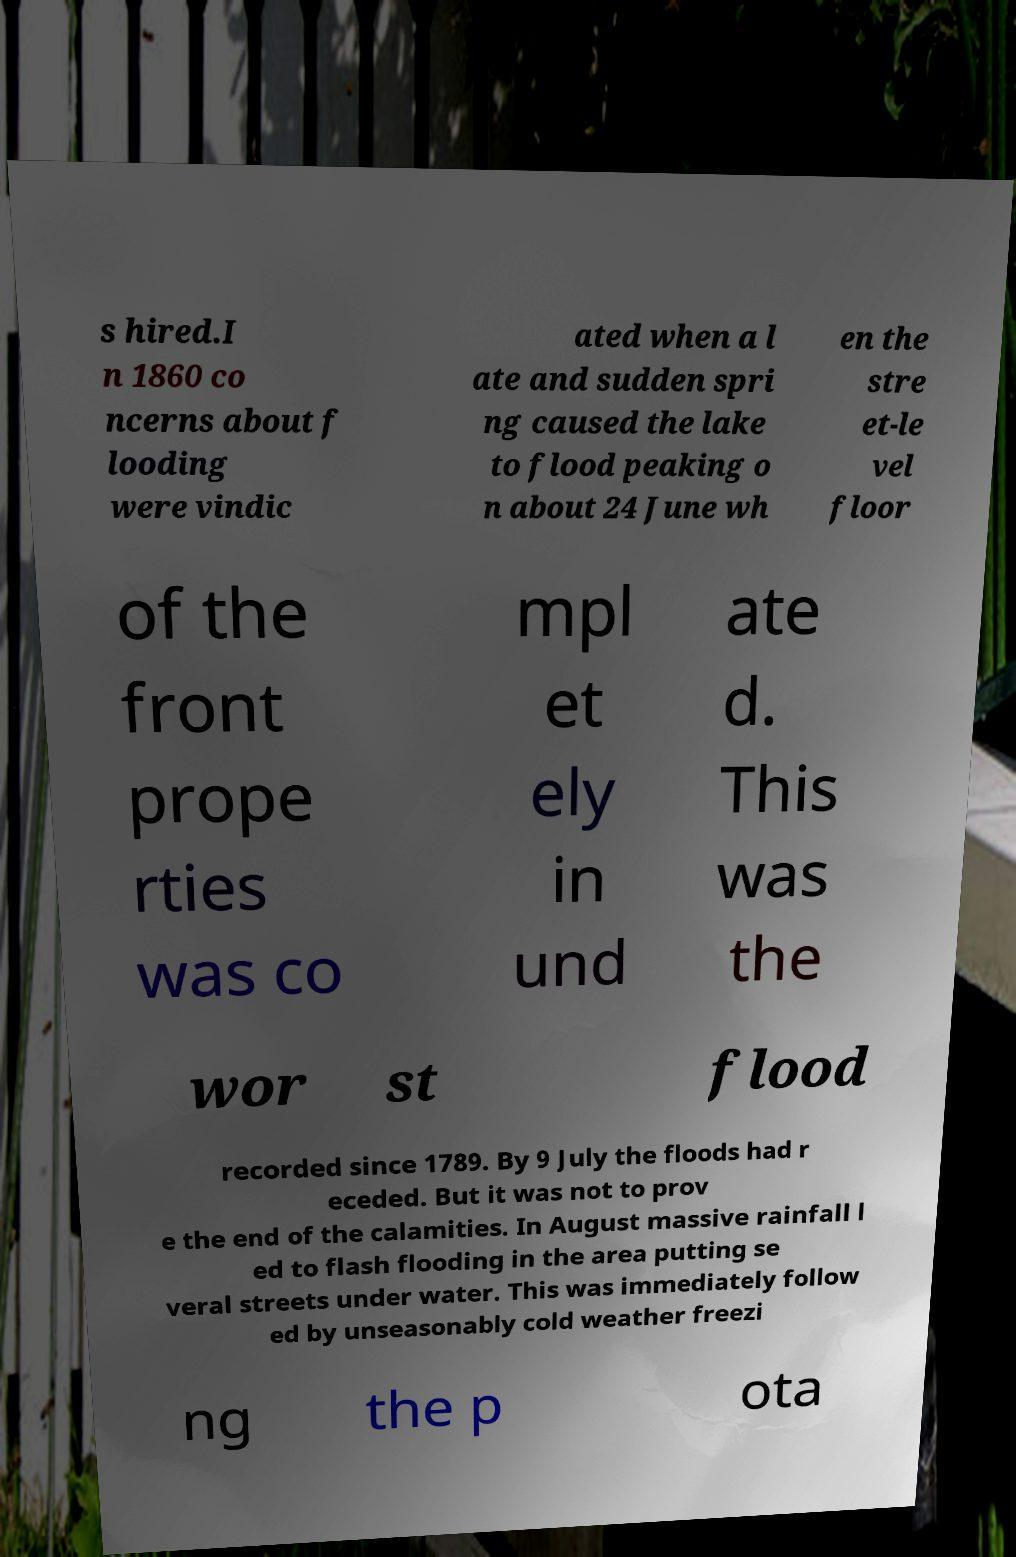Could you assist in decoding the text presented in this image and type it out clearly? s hired.I n 1860 co ncerns about f looding were vindic ated when a l ate and sudden spri ng caused the lake to flood peaking o n about 24 June wh en the stre et-le vel floor of the front prope rties was co mpl et ely in und ate d. This was the wor st flood recorded since 1789. By 9 July the floods had r eceded. But it was not to prov e the end of the calamities. In August massive rainfall l ed to flash flooding in the area putting se veral streets under water. This was immediately follow ed by unseasonably cold weather freezi ng the p ota 